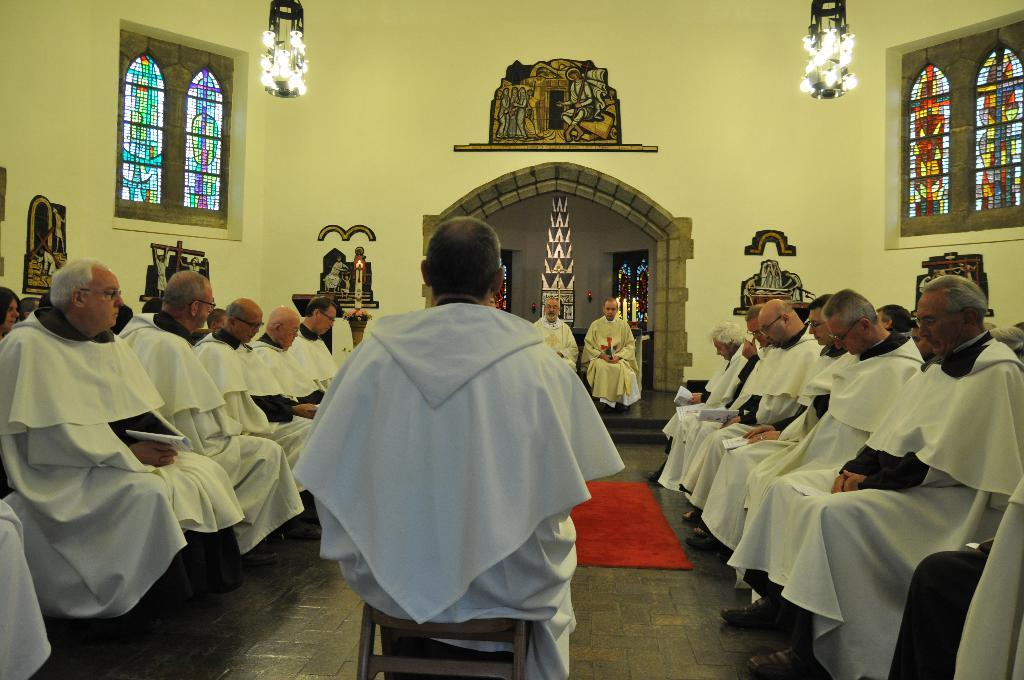How many lights can be seen in the image? There are two lights in the image. What other architectural features are present in the image? There are windows in the image. What is the color of the wall in the image? The wall has a yellow color. What is on the ground in the image? There is a mat on the ground. What are the people in the image doing? There are people sitting on chairs in the image. Can you tell me the route the duck takes to get to the window in the image? There is no duck present in the image, so it is not possible to determine a route. 